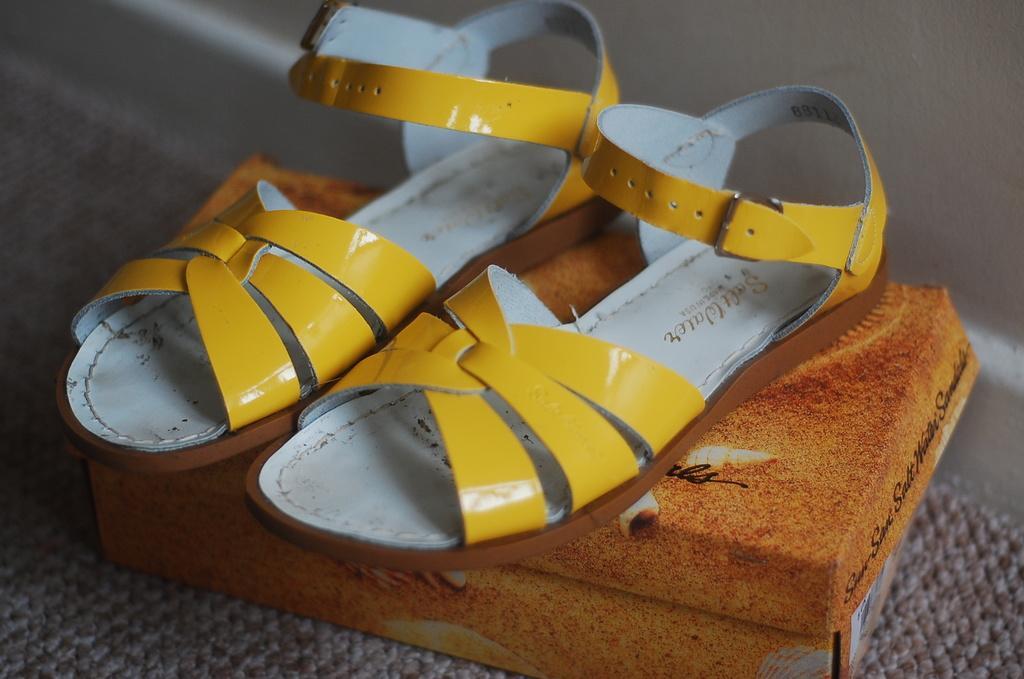How would you summarize this image in a sentence or two? In this image there is a footwear on the box in the center. 